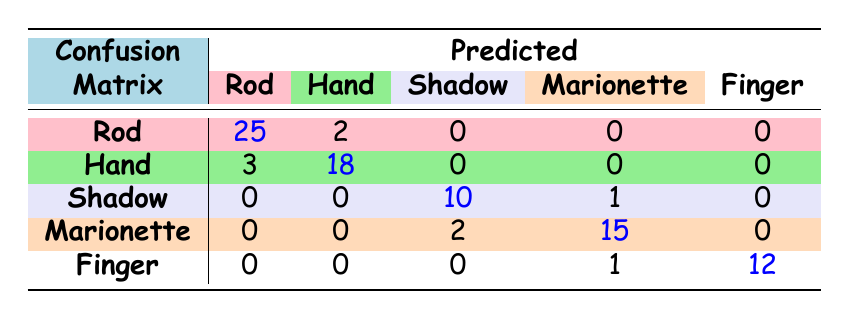What is the predicted count of Rod Puppets? The table indicates that the predicted count of Rod Puppets is located in the Rod Puppet row under the Rod column. It shows a value of 25.
Answer: 25 How many Hand Puppets were misclassified as Rod Puppets? In the Hand Puppet row, the Rod column indicates that 3 predictions were misclassified.
Answer: 3 What is the total number of Shadow Puppet predictions? To find the total number of Shadow Puppet predictions, we sum the counts from the Shadow Puppet row: 10 (correct) + 1 (misclassified as Marionette) = 11.
Answer: 11 Is the number of correctly predicted Hand Puppets greater than the number of misclassified Rod Puppets? Yes, the correctly predicted Hand Puppets, which is 18, is compared to the misclassified Rod Puppets which is 2. Since 18 is greater than 2, the answer is yes.
Answer: Yes What is the difference in the number of correctly predicted Marionettes and the number of Shadow Puppets misclassified as Marionettes? The number of correctly predicted Marionettes is 15, while the number of Shadow Puppets misclassified as Marionettes is 1. The difference is 15 - 1 = 14.
Answer: 14 How many total predictions were made for Finger Puppets? For Finger Puppets, looking at the Finger row, the total predictions made can be counted from the Finger row: 12 (correct) + 1 (misclassified as Marionette) = 13.
Answer: 13 What percentage of Rod Puppet predictions were correct? The total predictions for Rod Puppets is the sum of correctly predicted (25) and misclassified as other types (2). This gives a total of 27. The percentage of correct predictions is (25/27) * 100, which is approximately 92.59%.
Answer: Approximately 92.59% Are all Shadow Puppet actual values predicted correctly? No, in looking at the row for Shadow Puppets, the value under the Rod column shows that there were no correct predictions recorded for them, leading to a conclusion that not all were predicted correctly.
Answer: No What is the total number of predictions that were classified as Marionettes? Sum the counts in the Marionette row: 15 (correct) + 2 (misclassified as Shadow) + 1 (misclassified as Finger) = 18.
Answer: 18 